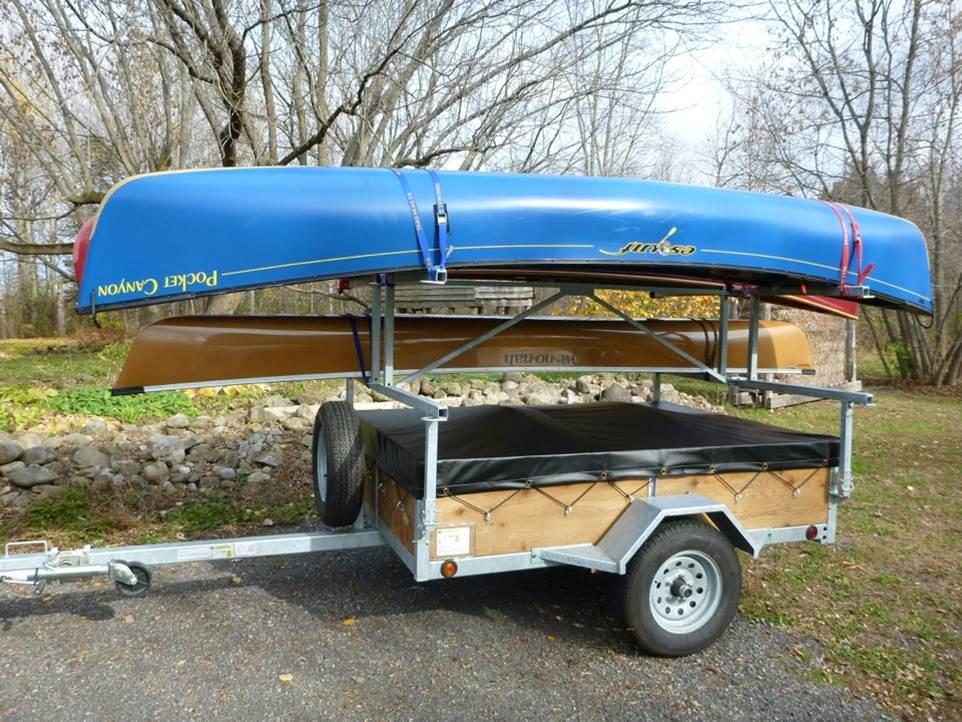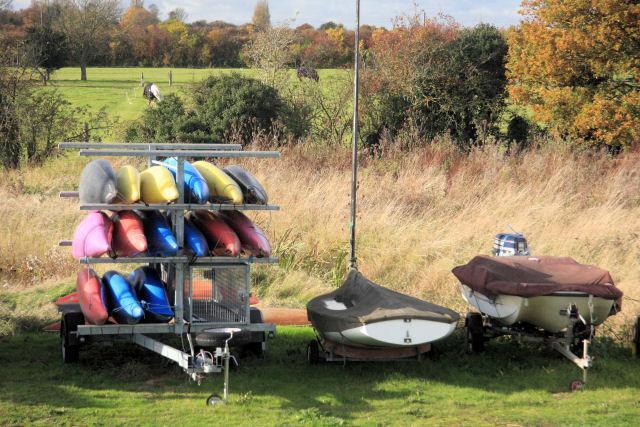The first image is the image on the left, the second image is the image on the right. Analyze the images presented: Is the assertion "An image shows two orange boats atop a trailer." valid? Answer yes or no. No. The first image is the image on the left, the second image is the image on the right. For the images displayed, is the sentence "There are at least five canoes in the image on the left." factually correct? Answer yes or no. No. 